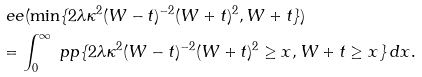Convert formula to latex. <formula><loc_0><loc_0><loc_500><loc_500>& \ e e ( \min \{ 2 \lambda \kappa ^ { 2 } ( W - t ) ^ { - 2 } ( W + t ) ^ { 2 } , W + t \} ) \\ & = \int _ { 0 } ^ { \infty } \ p p \{ 2 \lambda \kappa ^ { 2 } ( W - t ) ^ { - 2 } ( W + t ) ^ { 2 } \geq x , W + t \geq x \} \, d x .</formula> 